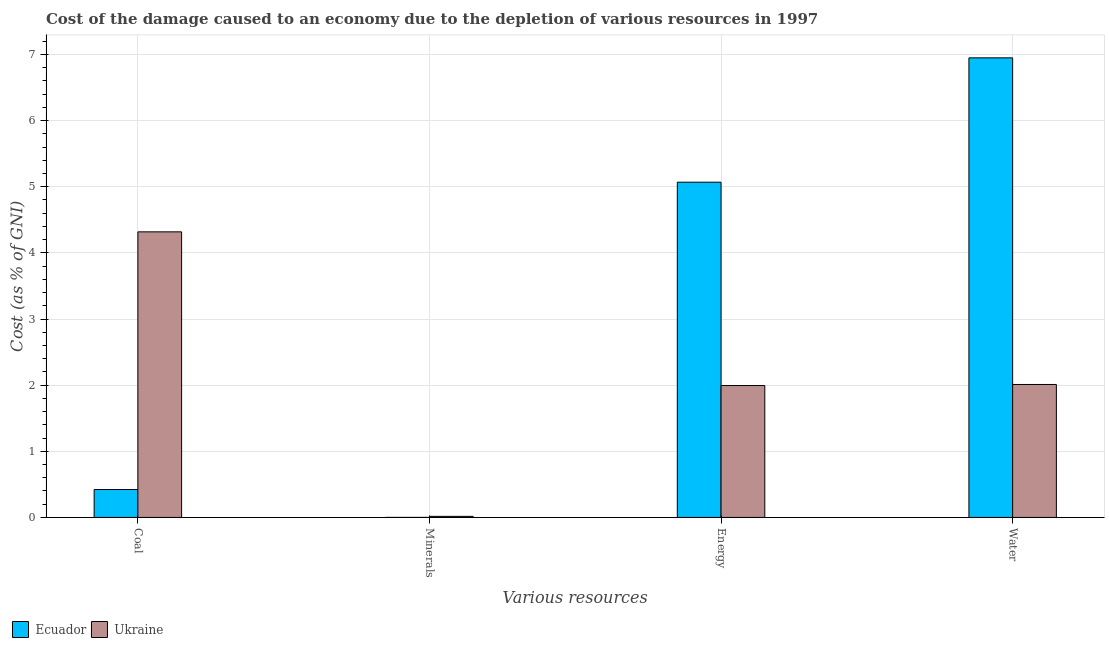Are the number of bars on each tick of the X-axis equal?
Keep it short and to the point. Yes. What is the label of the 1st group of bars from the left?
Give a very brief answer. Coal. What is the cost of damage due to depletion of coal in Ukraine?
Provide a short and direct response. 4.32. Across all countries, what is the maximum cost of damage due to depletion of energy?
Offer a very short reply. 5.07. Across all countries, what is the minimum cost of damage due to depletion of minerals?
Provide a succinct answer. 0. In which country was the cost of damage due to depletion of water maximum?
Ensure brevity in your answer.  Ecuador. In which country was the cost of damage due to depletion of water minimum?
Ensure brevity in your answer.  Ukraine. What is the total cost of damage due to depletion of coal in the graph?
Provide a succinct answer. 4.74. What is the difference between the cost of damage due to depletion of coal in Ukraine and that in Ecuador?
Your answer should be compact. 3.9. What is the difference between the cost of damage due to depletion of minerals in Ecuador and the cost of damage due to depletion of water in Ukraine?
Your answer should be very brief. -2.01. What is the average cost of damage due to depletion of energy per country?
Your answer should be compact. 3.53. What is the difference between the cost of damage due to depletion of coal and cost of damage due to depletion of energy in Ukraine?
Provide a short and direct response. 2.32. In how many countries, is the cost of damage due to depletion of energy greater than 4.2 %?
Provide a succinct answer. 1. What is the ratio of the cost of damage due to depletion of minerals in Ukraine to that in Ecuador?
Offer a very short reply. 100.53. Is the cost of damage due to depletion of water in Ukraine less than that in Ecuador?
Keep it short and to the point. Yes. Is the difference between the cost of damage due to depletion of coal in Ecuador and Ukraine greater than the difference between the cost of damage due to depletion of water in Ecuador and Ukraine?
Your response must be concise. No. What is the difference between the highest and the second highest cost of damage due to depletion of coal?
Offer a very short reply. 3.9. What is the difference between the highest and the lowest cost of damage due to depletion of minerals?
Ensure brevity in your answer.  0.02. In how many countries, is the cost of damage due to depletion of energy greater than the average cost of damage due to depletion of energy taken over all countries?
Offer a very short reply. 1. Is the sum of the cost of damage due to depletion of minerals in Ukraine and Ecuador greater than the maximum cost of damage due to depletion of coal across all countries?
Provide a succinct answer. No. Is it the case that in every country, the sum of the cost of damage due to depletion of minerals and cost of damage due to depletion of water is greater than the sum of cost of damage due to depletion of coal and cost of damage due to depletion of energy?
Provide a short and direct response. No. What does the 2nd bar from the left in Energy represents?
Offer a terse response. Ukraine. What does the 1st bar from the right in Coal represents?
Offer a very short reply. Ukraine. How many bars are there?
Offer a terse response. 8. Are all the bars in the graph horizontal?
Offer a terse response. No. What is the difference between two consecutive major ticks on the Y-axis?
Your answer should be compact. 1. Does the graph contain any zero values?
Provide a short and direct response. No. How are the legend labels stacked?
Ensure brevity in your answer.  Horizontal. What is the title of the graph?
Keep it short and to the point. Cost of the damage caused to an economy due to the depletion of various resources in 1997 . Does "Channel Islands" appear as one of the legend labels in the graph?
Make the answer very short. No. What is the label or title of the X-axis?
Provide a short and direct response. Various resources. What is the label or title of the Y-axis?
Provide a short and direct response. Cost (as % of GNI). What is the Cost (as % of GNI) of Ecuador in Coal?
Offer a terse response. 0.42. What is the Cost (as % of GNI) in Ukraine in Coal?
Make the answer very short. 4.32. What is the Cost (as % of GNI) of Ecuador in Minerals?
Ensure brevity in your answer.  0. What is the Cost (as % of GNI) in Ukraine in Minerals?
Keep it short and to the point. 0.02. What is the Cost (as % of GNI) of Ecuador in Energy?
Give a very brief answer. 5.07. What is the Cost (as % of GNI) in Ukraine in Energy?
Provide a short and direct response. 1.99. What is the Cost (as % of GNI) of Ecuador in Water?
Provide a short and direct response. 6.95. What is the Cost (as % of GNI) of Ukraine in Water?
Your answer should be very brief. 2.01. Across all Various resources, what is the maximum Cost (as % of GNI) of Ecuador?
Keep it short and to the point. 6.95. Across all Various resources, what is the maximum Cost (as % of GNI) in Ukraine?
Offer a terse response. 4.32. Across all Various resources, what is the minimum Cost (as % of GNI) of Ecuador?
Provide a short and direct response. 0. Across all Various resources, what is the minimum Cost (as % of GNI) of Ukraine?
Offer a very short reply. 0.02. What is the total Cost (as % of GNI) in Ecuador in the graph?
Provide a succinct answer. 12.44. What is the total Cost (as % of GNI) of Ukraine in the graph?
Offer a terse response. 8.34. What is the difference between the Cost (as % of GNI) of Ecuador in Coal and that in Minerals?
Your response must be concise. 0.42. What is the difference between the Cost (as % of GNI) in Ukraine in Coal and that in Minerals?
Your answer should be compact. 4.3. What is the difference between the Cost (as % of GNI) of Ecuador in Coal and that in Energy?
Offer a very short reply. -4.65. What is the difference between the Cost (as % of GNI) of Ukraine in Coal and that in Energy?
Your answer should be compact. 2.32. What is the difference between the Cost (as % of GNI) in Ecuador in Coal and that in Water?
Your answer should be very brief. -6.53. What is the difference between the Cost (as % of GNI) in Ukraine in Coal and that in Water?
Ensure brevity in your answer.  2.31. What is the difference between the Cost (as % of GNI) of Ecuador in Minerals and that in Energy?
Give a very brief answer. -5.07. What is the difference between the Cost (as % of GNI) in Ukraine in Minerals and that in Energy?
Offer a terse response. -1.98. What is the difference between the Cost (as % of GNI) in Ecuador in Minerals and that in Water?
Your answer should be very brief. -6.95. What is the difference between the Cost (as % of GNI) of Ukraine in Minerals and that in Water?
Offer a very short reply. -1.99. What is the difference between the Cost (as % of GNI) in Ecuador in Energy and that in Water?
Your answer should be very brief. -1.88. What is the difference between the Cost (as % of GNI) in Ukraine in Energy and that in Water?
Make the answer very short. -0.02. What is the difference between the Cost (as % of GNI) of Ecuador in Coal and the Cost (as % of GNI) of Ukraine in Minerals?
Offer a very short reply. 0.41. What is the difference between the Cost (as % of GNI) of Ecuador in Coal and the Cost (as % of GNI) of Ukraine in Energy?
Provide a succinct answer. -1.57. What is the difference between the Cost (as % of GNI) of Ecuador in Coal and the Cost (as % of GNI) of Ukraine in Water?
Offer a terse response. -1.59. What is the difference between the Cost (as % of GNI) of Ecuador in Minerals and the Cost (as % of GNI) of Ukraine in Energy?
Provide a short and direct response. -1.99. What is the difference between the Cost (as % of GNI) in Ecuador in Minerals and the Cost (as % of GNI) in Ukraine in Water?
Your answer should be very brief. -2.01. What is the difference between the Cost (as % of GNI) of Ecuador in Energy and the Cost (as % of GNI) of Ukraine in Water?
Your response must be concise. 3.06. What is the average Cost (as % of GNI) in Ecuador per Various resources?
Your response must be concise. 3.11. What is the average Cost (as % of GNI) in Ukraine per Various resources?
Your response must be concise. 2.08. What is the difference between the Cost (as % of GNI) in Ecuador and Cost (as % of GNI) in Ukraine in Coal?
Your response must be concise. -3.9. What is the difference between the Cost (as % of GNI) of Ecuador and Cost (as % of GNI) of Ukraine in Minerals?
Make the answer very short. -0.02. What is the difference between the Cost (as % of GNI) in Ecuador and Cost (as % of GNI) in Ukraine in Energy?
Your response must be concise. 3.07. What is the difference between the Cost (as % of GNI) of Ecuador and Cost (as % of GNI) of Ukraine in Water?
Provide a succinct answer. 4.94. What is the ratio of the Cost (as % of GNI) in Ecuador in Coal to that in Minerals?
Your answer should be very brief. 2659.94. What is the ratio of the Cost (as % of GNI) in Ukraine in Coal to that in Minerals?
Provide a succinct answer. 270.73. What is the ratio of the Cost (as % of GNI) of Ecuador in Coal to that in Energy?
Your answer should be compact. 0.08. What is the ratio of the Cost (as % of GNI) of Ukraine in Coal to that in Energy?
Keep it short and to the point. 2.17. What is the ratio of the Cost (as % of GNI) of Ecuador in Coal to that in Water?
Your answer should be very brief. 0.06. What is the ratio of the Cost (as % of GNI) of Ukraine in Coal to that in Water?
Offer a terse response. 2.15. What is the ratio of the Cost (as % of GNI) of Ecuador in Minerals to that in Energy?
Give a very brief answer. 0. What is the ratio of the Cost (as % of GNI) of Ukraine in Minerals to that in Energy?
Provide a succinct answer. 0.01. What is the ratio of the Cost (as % of GNI) in Ecuador in Minerals to that in Water?
Offer a very short reply. 0. What is the ratio of the Cost (as % of GNI) of Ukraine in Minerals to that in Water?
Offer a terse response. 0.01. What is the ratio of the Cost (as % of GNI) in Ecuador in Energy to that in Water?
Ensure brevity in your answer.  0.73. What is the difference between the highest and the second highest Cost (as % of GNI) in Ecuador?
Provide a short and direct response. 1.88. What is the difference between the highest and the second highest Cost (as % of GNI) in Ukraine?
Offer a very short reply. 2.31. What is the difference between the highest and the lowest Cost (as % of GNI) in Ecuador?
Make the answer very short. 6.95. What is the difference between the highest and the lowest Cost (as % of GNI) of Ukraine?
Offer a very short reply. 4.3. 